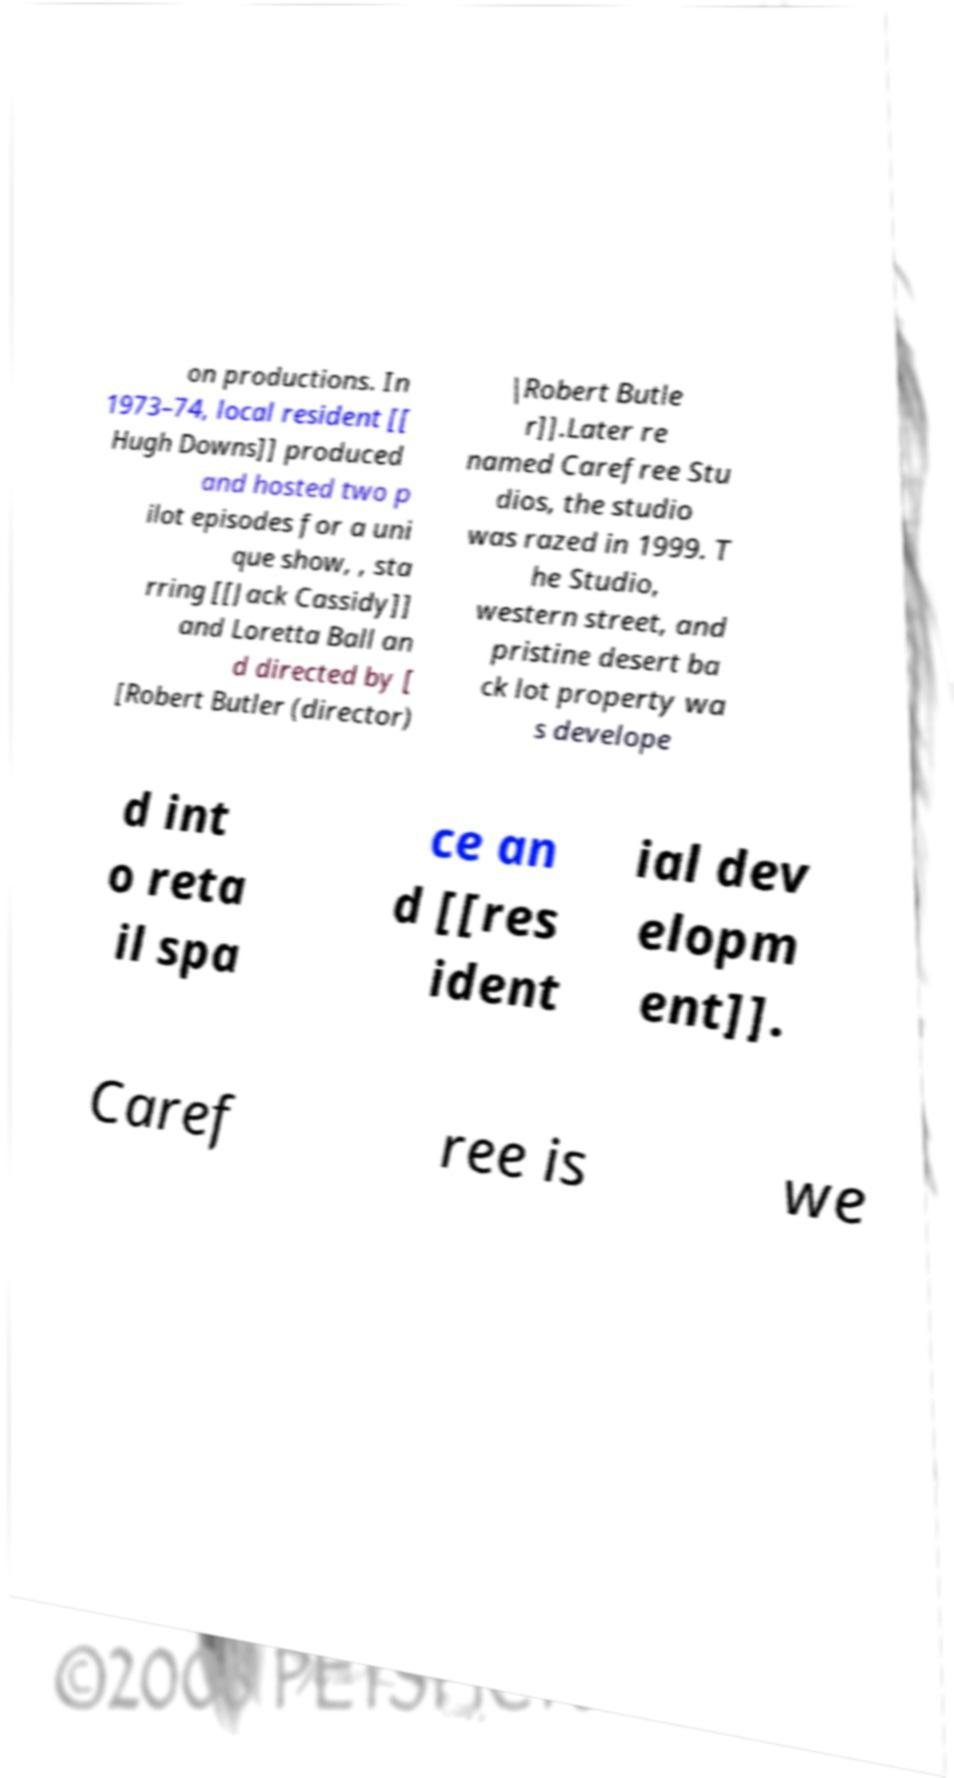I need the written content from this picture converted into text. Can you do that? on productions. In 1973–74, local resident [[ Hugh Downs]] produced and hosted two p ilot episodes for a uni que show, , sta rring [[Jack Cassidy]] and Loretta Ball an d directed by [ [Robert Butler (director) |Robert Butle r]].Later re named Carefree Stu dios, the studio was razed in 1999. T he Studio, western street, and pristine desert ba ck lot property wa s develope d int o reta il spa ce an d [[res ident ial dev elopm ent]]. Caref ree is we 